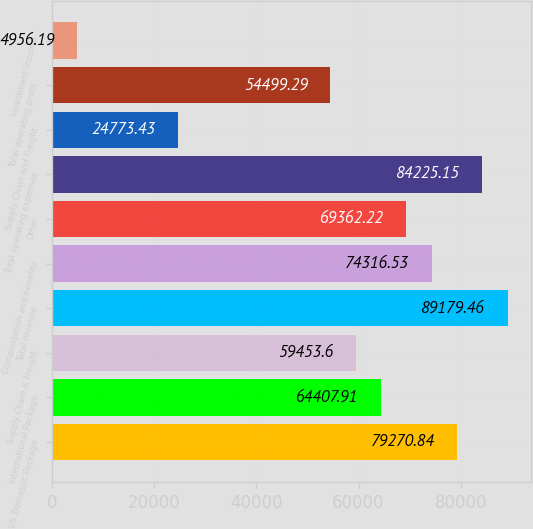<chart> <loc_0><loc_0><loc_500><loc_500><bar_chart><fcel>US Domestic Package<fcel>International Package<fcel>Supply Chain & Freight<fcel>Total revenue<fcel>Compensation and benefits<fcel>Other<fcel>Total operating expenses<fcel>Supply Chain and Freight<fcel>Total operating profit<fcel>Investment income<nl><fcel>79270.8<fcel>64407.9<fcel>59453.6<fcel>89179.5<fcel>74316.5<fcel>69362.2<fcel>84225.1<fcel>24773.4<fcel>54499.3<fcel>4956.19<nl></chart> 